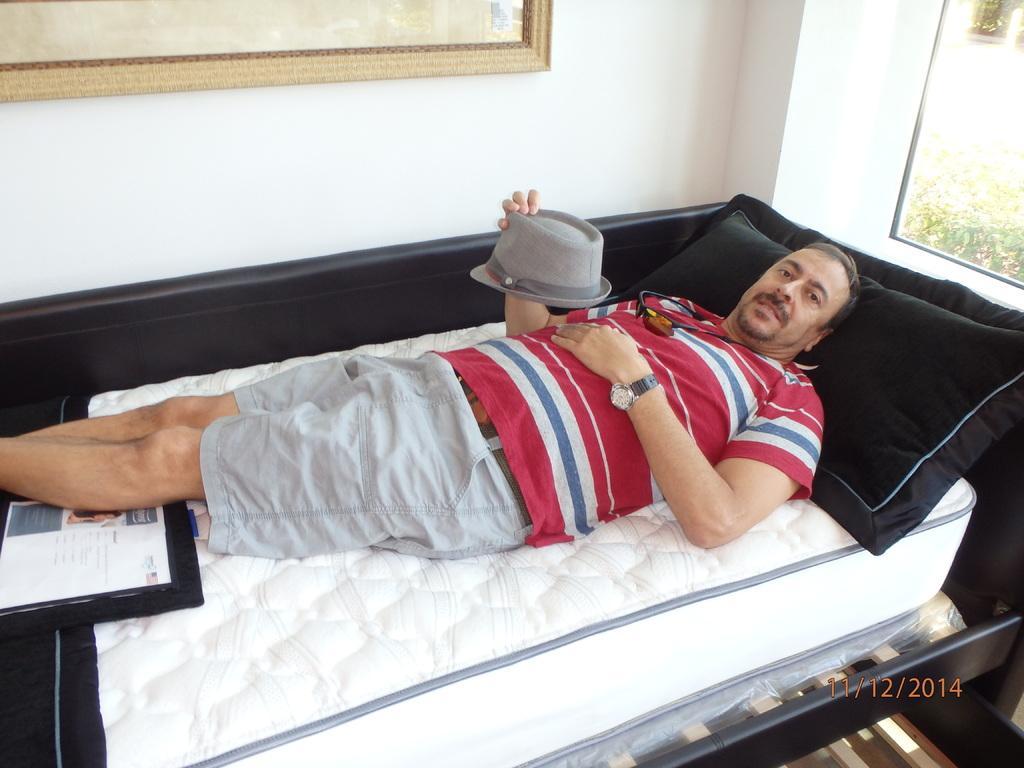Please provide a concise description of this image. In this image there is a man who is sleeping on the bed and holding the cap in his hand. There is a pillow under his head. At the background there is a wall and a frame on it. 